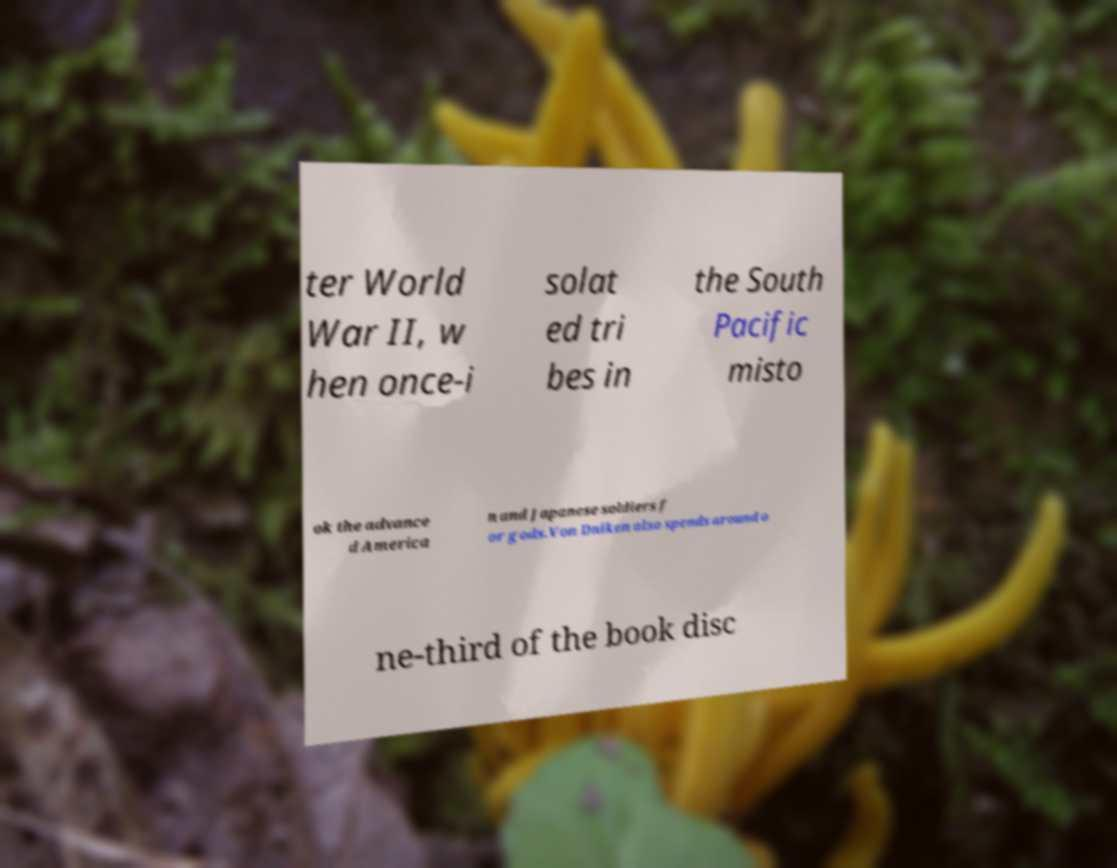Could you extract and type out the text from this image? ter World War II, w hen once-i solat ed tri bes in the South Pacific misto ok the advance d America n and Japanese soldiers f or gods.Von Dniken also spends around o ne-third of the book disc 